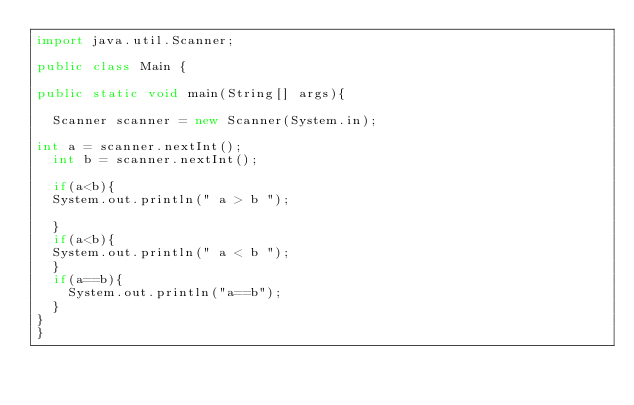Convert code to text. <code><loc_0><loc_0><loc_500><loc_500><_Java_>import java.util.Scanner;

public class Main {

public static void main(String[] args){
	
	Scanner scanner = new Scanner(System.in);

int a = scanner.nextInt();
	int b = scanner.nextInt();

	if(a<b){
	System.out.println(" a > b ");
	
	}
	if(a<b){
	System.out.println(" a < b ");
	}
	if(a==b){
		System.out.println("a==b");
	}
}
}</code> 